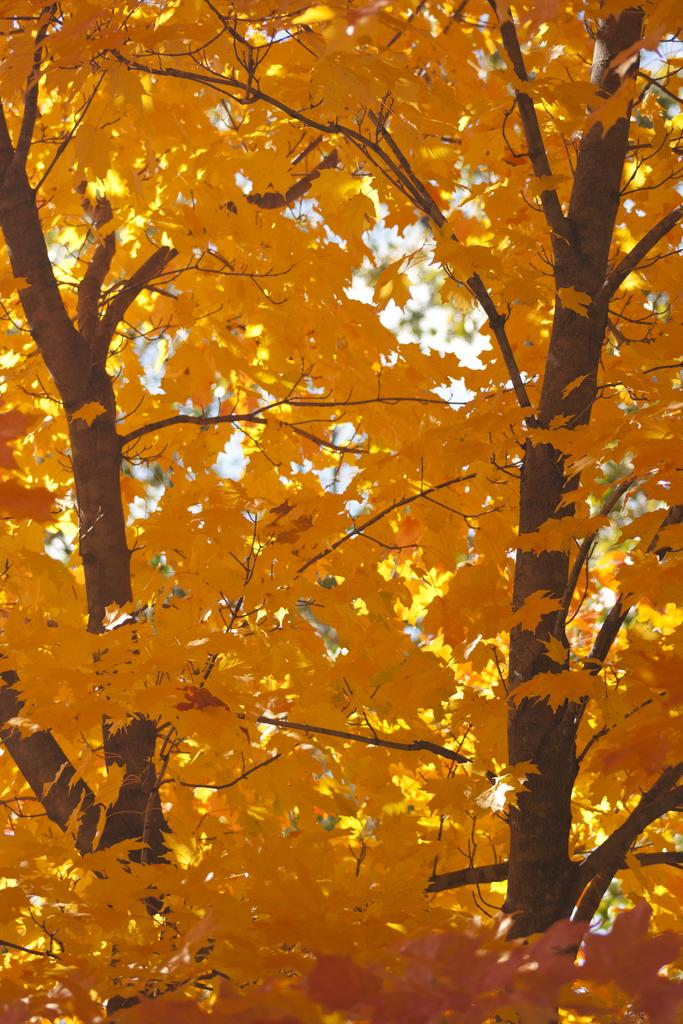What type of natural element can be seen in the image? There is a tree in the image. Can you describe the tree in the image? The provided facts do not include a description of the tree, so we cannot provide specific details about its appearance. What type of medical advice does the tree provide in the image? There is no indication in the image that the tree is providing medical advice or that a doctor is present. 